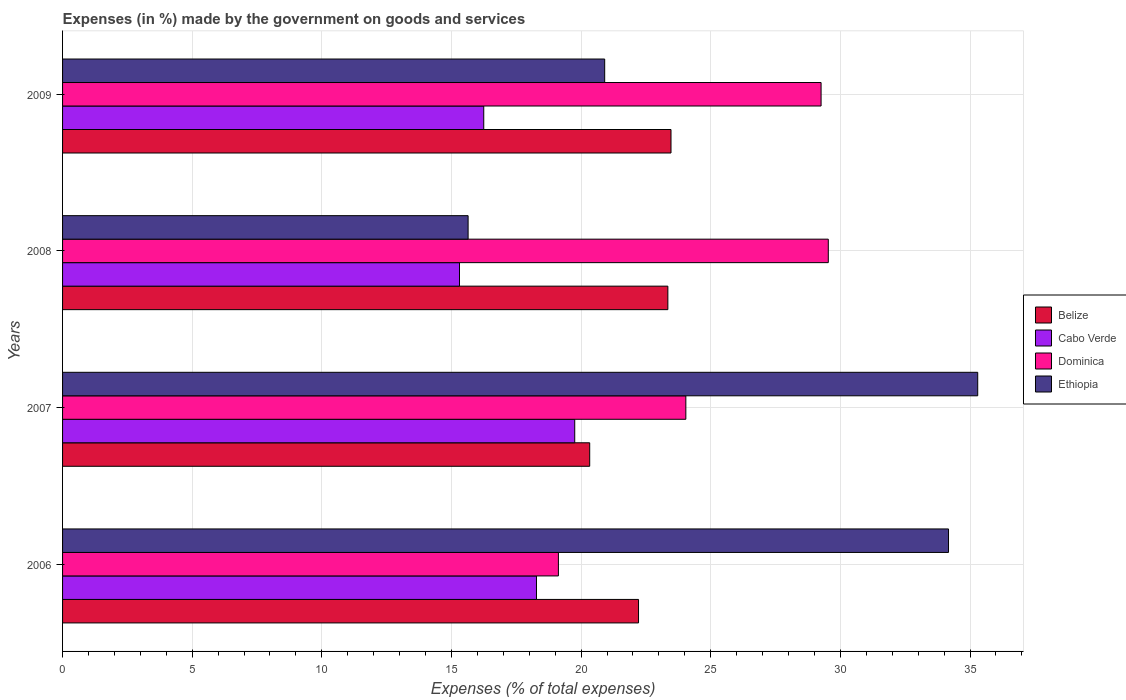How many bars are there on the 4th tick from the bottom?
Offer a very short reply. 4. In how many cases, is the number of bars for a given year not equal to the number of legend labels?
Keep it short and to the point. 0. What is the percentage of expenses made by the government on goods and services in Dominica in 2006?
Provide a succinct answer. 19.12. Across all years, what is the maximum percentage of expenses made by the government on goods and services in Ethiopia?
Provide a short and direct response. 35.3. Across all years, what is the minimum percentage of expenses made by the government on goods and services in Cabo Verde?
Your answer should be compact. 15.31. In which year was the percentage of expenses made by the government on goods and services in Cabo Verde minimum?
Offer a very short reply. 2008. What is the total percentage of expenses made by the government on goods and services in Belize in the graph?
Offer a very short reply. 89.36. What is the difference between the percentage of expenses made by the government on goods and services in Belize in 2007 and that in 2009?
Make the answer very short. -3.14. What is the difference between the percentage of expenses made by the government on goods and services in Cabo Verde in 2009 and the percentage of expenses made by the government on goods and services in Dominica in 2007?
Your answer should be very brief. -7.79. What is the average percentage of expenses made by the government on goods and services in Dominica per year?
Your answer should be compact. 25.49. In the year 2008, what is the difference between the percentage of expenses made by the government on goods and services in Belize and percentage of expenses made by the government on goods and services in Ethiopia?
Your answer should be very brief. 7.7. What is the ratio of the percentage of expenses made by the government on goods and services in Cabo Verde in 2006 to that in 2008?
Offer a very short reply. 1.19. Is the difference between the percentage of expenses made by the government on goods and services in Belize in 2006 and 2009 greater than the difference between the percentage of expenses made by the government on goods and services in Ethiopia in 2006 and 2009?
Ensure brevity in your answer.  No. What is the difference between the highest and the second highest percentage of expenses made by the government on goods and services in Ethiopia?
Keep it short and to the point. 1.13. What is the difference between the highest and the lowest percentage of expenses made by the government on goods and services in Belize?
Your answer should be compact. 3.14. In how many years, is the percentage of expenses made by the government on goods and services in Dominica greater than the average percentage of expenses made by the government on goods and services in Dominica taken over all years?
Offer a terse response. 2. What does the 3rd bar from the top in 2008 represents?
Ensure brevity in your answer.  Cabo Verde. What does the 3rd bar from the bottom in 2007 represents?
Make the answer very short. Dominica. How many bars are there?
Your answer should be very brief. 16. How many years are there in the graph?
Offer a very short reply. 4. What is the difference between two consecutive major ticks on the X-axis?
Make the answer very short. 5. Are the values on the major ticks of X-axis written in scientific E-notation?
Provide a short and direct response. No. How many legend labels are there?
Keep it short and to the point. 4. How are the legend labels stacked?
Your answer should be very brief. Vertical. What is the title of the graph?
Keep it short and to the point. Expenses (in %) made by the government on goods and services. Does "Samoa" appear as one of the legend labels in the graph?
Provide a succinct answer. No. What is the label or title of the X-axis?
Your response must be concise. Expenses (% of total expenses). What is the label or title of the Y-axis?
Your answer should be very brief. Years. What is the Expenses (% of total expenses) of Belize in 2006?
Your answer should be compact. 22.21. What is the Expenses (% of total expenses) of Cabo Verde in 2006?
Make the answer very short. 18.28. What is the Expenses (% of total expenses) in Dominica in 2006?
Provide a short and direct response. 19.12. What is the Expenses (% of total expenses) of Ethiopia in 2006?
Your response must be concise. 34.17. What is the Expenses (% of total expenses) of Belize in 2007?
Provide a short and direct response. 20.33. What is the Expenses (% of total expenses) in Cabo Verde in 2007?
Make the answer very short. 19.75. What is the Expenses (% of total expenses) in Dominica in 2007?
Ensure brevity in your answer.  24.04. What is the Expenses (% of total expenses) in Ethiopia in 2007?
Provide a short and direct response. 35.3. What is the Expenses (% of total expenses) of Belize in 2008?
Provide a short and direct response. 23.35. What is the Expenses (% of total expenses) in Cabo Verde in 2008?
Make the answer very short. 15.31. What is the Expenses (% of total expenses) in Dominica in 2008?
Your answer should be very brief. 29.53. What is the Expenses (% of total expenses) of Ethiopia in 2008?
Your answer should be compact. 15.64. What is the Expenses (% of total expenses) of Belize in 2009?
Your answer should be very brief. 23.47. What is the Expenses (% of total expenses) in Cabo Verde in 2009?
Give a very brief answer. 16.24. What is the Expenses (% of total expenses) in Dominica in 2009?
Offer a very short reply. 29.25. What is the Expenses (% of total expenses) of Ethiopia in 2009?
Your answer should be compact. 20.91. Across all years, what is the maximum Expenses (% of total expenses) of Belize?
Your answer should be compact. 23.47. Across all years, what is the maximum Expenses (% of total expenses) of Cabo Verde?
Give a very brief answer. 19.75. Across all years, what is the maximum Expenses (% of total expenses) of Dominica?
Provide a succinct answer. 29.53. Across all years, what is the maximum Expenses (% of total expenses) in Ethiopia?
Give a very brief answer. 35.3. Across all years, what is the minimum Expenses (% of total expenses) of Belize?
Your response must be concise. 20.33. Across all years, what is the minimum Expenses (% of total expenses) of Cabo Verde?
Your answer should be very brief. 15.31. Across all years, what is the minimum Expenses (% of total expenses) of Dominica?
Provide a short and direct response. 19.12. Across all years, what is the minimum Expenses (% of total expenses) of Ethiopia?
Offer a very short reply. 15.64. What is the total Expenses (% of total expenses) in Belize in the graph?
Make the answer very short. 89.36. What is the total Expenses (% of total expenses) of Cabo Verde in the graph?
Offer a very short reply. 69.59. What is the total Expenses (% of total expenses) in Dominica in the graph?
Make the answer very short. 101.95. What is the total Expenses (% of total expenses) of Ethiopia in the graph?
Offer a very short reply. 106.02. What is the difference between the Expenses (% of total expenses) of Belize in 2006 and that in 2007?
Keep it short and to the point. 1.88. What is the difference between the Expenses (% of total expenses) of Cabo Verde in 2006 and that in 2007?
Ensure brevity in your answer.  -1.48. What is the difference between the Expenses (% of total expenses) of Dominica in 2006 and that in 2007?
Your answer should be compact. -4.92. What is the difference between the Expenses (% of total expenses) in Ethiopia in 2006 and that in 2007?
Offer a very short reply. -1.13. What is the difference between the Expenses (% of total expenses) in Belize in 2006 and that in 2008?
Provide a succinct answer. -1.13. What is the difference between the Expenses (% of total expenses) of Cabo Verde in 2006 and that in 2008?
Offer a terse response. 2.97. What is the difference between the Expenses (% of total expenses) of Dominica in 2006 and that in 2008?
Make the answer very short. -10.41. What is the difference between the Expenses (% of total expenses) of Ethiopia in 2006 and that in 2008?
Keep it short and to the point. 18.53. What is the difference between the Expenses (% of total expenses) of Belize in 2006 and that in 2009?
Offer a terse response. -1.25. What is the difference between the Expenses (% of total expenses) of Cabo Verde in 2006 and that in 2009?
Offer a terse response. 2.03. What is the difference between the Expenses (% of total expenses) of Dominica in 2006 and that in 2009?
Offer a terse response. -10.13. What is the difference between the Expenses (% of total expenses) in Ethiopia in 2006 and that in 2009?
Offer a very short reply. 13.26. What is the difference between the Expenses (% of total expenses) of Belize in 2007 and that in 2008?
Make the answer very short. -3.01. What is the difference between the Expenses (% of total expenses) in Cabo Verde in 2007 and that in 2008?
Offer a terse response. 4.44. What is the difference between the Expenses (% of total expenses) in Dominica in 2007 and that in 2008?
Give a very brief answer. -5.49. What is the difference between the Expenses (% of total expenses) in Ethiopia in 2007 and that in 2008?
Offer a very short reply. 19.65. What is the difference between the Expenses (% of total expenses) in Belize in 2007 and that in 2009?
Your answer should be compact. -3.14. What is the difference between the Expenses (% of total expenses) of Cabo Verde in 2007 and that in 2009?
Your response must be concise. 3.51. What is the difference between the Expenses (% of total expenses) of Dominica in 2007 and that in 2009?
Ensure brevity in your answer.  -5.22. What is the difference between the Expenses (% of total expenses) in Ethiopia in 2007 and that in 2009?
Offer a terse response. 14.39. What is the difference between the Expenses (% of total expenses) of Belize in 2008 and that in 2009?
Give a very brief answer. -0.12. What is the difference between the Expenses (% of total expenses) in Cabo Verde in 2008 and that in 2009?
Keep it short and to the point. -0.94. What is the difference between the Expenses (% of total expenses) of Dominica in 2008 and that in 2009?
Offer a terse response. 0.28. What is the difference between the Expenses (% of total expenses) of Ethiopia in 2008 and that in 2009?
Provide a succinct answer. -5.27. What is the difference between the Expenses (% of total expenses) of Belize in 2006 and the Expenses (% of total expenses) of Cabo Verde in 2007?
Your answer should be compact. 2.46. What is the difference between the Expenses (% of total expenses) in Belize in 2006 and the Expenses (% of total expenses) in Dominica in 2007?
Offer a terse response. -1.82. What is the difference between the Expenses (% of total expenses) in Belize in 2006 and the Expenses (% of total expenses) in Ethiopia in 2007?
Ensure brevity in your answer.  -13.08. What is the difference between the Expenses (% of total expenses) in Cabo Verde in 2006 and the Expenses (% of total expenses) in Dominica in 2007?
Provide a short and direct response. -5.76. What is the difference between the Expenses (% of total expenses) in Cabo Verde in 2006 and the Expenses (% of total expenses) in Ethiopia in 2007?
Your response must be concise. -17.02. What is the difference between the Expenses (% of total expenses) of Dominica in 2006 and the Expenses (% of total expenses) of Ethiopia in 2007?
Your answer should be compact. -16.17. What is the difference between the Expenses (% of total expenses) of Belize in 2006 and the Expenses (% of total expenses) of Cabo Verde in 2008?
Give a very brief answer. 6.9. What is the difference between the Expenses (% of total expenses) in Belize in 2006 and the Expenses (% of total expenses) in Dominica in 2008?
Make the answer very short. -7.32. What is the difference between the Expenses (% of total expenses) in Belize in 2006 and the Expenses (% of total expenses) in Ethiopia in 2008?
Your response must be concise. 6.57. What is the difference between the Expenses (% of total expenses) of Cabo Verde in 2006 and the Expenses (% of total expenses) of Dominica in 2008?
Offer a terse response. -11.26. What is the difference between the Expenses (% of total expenses) of Cabo Verde in 2006 and the Expenses (% of total expenses) of Ethiopia in 2008?
Ensure brevity in your answer.  2.64. What is the difference between the Expenses (% of total expenses) of Dominica in 2006 and the Expenses (% of total expenses) of Ethiopia in 2008?
Your answer should be very brief. 3.48. What is the difference between the Expenses (% of total expenses) in Belize in 2006 and the Expenses (% of total expenses) in Cabo Verde in 2009?
Your response must be concise. 5.97. What is the difference between the Expenses (% of total expenses) of Belize in 2006 and the Expenses (% of total expenses) of Dominica in 2009?
Your answer should be compact. -7.04. What is the difference between the Expenses (% of total expenses) of Belize in 2006 and the Expenses (% of total expenses) of Ethiopia in 2009?
Your answer should be compact. 1.3. What is the difference between the Expenses (% of total expenses) of Cabo Verde in 2006 and the Expenses (% of total expenses) of Dominica in 2009?
Provide a short and direct response. -10.98. What is the difference between the Expenses (% of total expenses) in Cabo Verde in 2006 and the Expenses (% of total expenses) in Ethiopia in 2009?
Your answer should be compact. -2.63. What is the difference between the Expenses (% of total expenses) of Dominica in 2006 and the Expenses (% of total expenses) of Ethiopia in 2009?
Offer a terse response. -1.79. What is the difference between the Expenses (% of total expenses) in Belize in 2007 and the Expenses (% of total expenses) in Cabo Verde in 2008?
Your answer should be compact. 5.02. What is the difference between the Expenses (% of total expenses) of Belize in 2007 and the Expenses (% of total expenses) of Dominica in 2008?
Make the answer very short. -9.2. What is the difference between the Expenses (% of total expenses) in Belize in 2007 and the Expenses (% of total expenses) in Ethiopia in 2008?
Make the answer very short. 4.69. What is the difference between the Expenses (% of total expenses) in Cabo Verde in 2007 and the Expenses (% of total expenses) in Dominica in 2008?
Your response must be concise. -9.78. What is the difference between the Expenses (% of total expenses) in Cabo Verde in 2007 and the Expenses (% of total expenses) in Ethiopia in 2008?
Your answer should be very brief. 4.11. What is the difference between the Expenses (% of total expenses) of Dominica in 2007 and the Expenses (% of total expenses) of Ethiopia in 2008?
Keep it short and to the point. 8.4. What is the difference between the Expenses (% of total expenses) in Belize in 2007 and the Expenses (% of total expenses) in Cabo Verde in 2009?
Your response must be concise. 4.09. What is the difference between the Expenses (% of total expenses) of Belize in 2007 and the Expenses (% of total expenses) of Dominica in 2009?
Offer a terse response. -8.92. What is the difference between the Expenses (% of total expenses) in Belize in 2007 and the Expenses (% of total expenses) in Ethiopia in 2009?
Your answer should be very brief. -0.58. What is the difference between the Expenses (% of total expenses) of Cabo Verde in 2007 and the Expenses (% of total expenses) of Dominica in 2009?
Your answer should be very brief. -9.5. What is the difference between the Expenses (% of total expenses) of Cabo Verde in 2007 and the Expenses (% of total expenses) of Ethiopia in 2009?
Your answer should be very brief. -1.16. What is the difference between the Expenses (% of total expenses) in Dominica in 2007 and the Expenses (% of total expenses) in Ethiopia in 2009?
Your answer should be very brief. 3.13. What is the difference between the Expenses (% of total expenses) of Belize in 2008 and the Expenses (% of total expenses) of Cabo Verde in 2009?
Provide a short and direct response. 7.1. What is the difference between the Expenses (% of total expenses) in Belize in 2008 and the Expenses (% of total expenses) in Dominica in 2009?
Your answer should be very brief. -5.91. What is the difference between the Expenses (% of total expenses) of Belize in 2008 and the Expenses (% of total expenses) of Ethiopia in 2009?
Your response must be concise. 2.44. What is the difference between the Expenses (% of total expenses) of Cabo Verde in 2008 and the Expenses (% of total expenses) of Dominica in 2009?
Ensure brevity in your answer.  -13.95. What is the difference between the Expenses (% of total expenses) of Cabo Verde in 2008 and the Expenses (% of total expenses) of Ethiopia in 2009?
Your response must be concise. -5.6. What is the difference between the Expenses (% of total expenses) in Dominica in 2008 and the Expenses (% of total expenses) in Ethiopia in 2009?
Give a very brief answer. 8.62. What is the average Expenses (% of total expenses) in Belize per year?
Ensure brevity in your answer.  22.34. What is the average Expenses (% of total expenses) of Cabo Verde per year?
Your answer should be very brief. 17.4. What is the average Expenses (% of total expenses) in Dominica per year?
Your response must be concise. 25.49. What is the average Expenses (% of total expenses) in Ethiopia per year?
Offer a very short reply. 26.5. In the year 2006, what is the difference between the Expenses (% of total expenses) of Belize and Expenses (% of total expenses) of Cabo Verde?
Your answer should be compact. 3.94. In the year 2006, what is the difference between the Expenses (% of total expenses) of Belize and Expenses (% of total expenses) of Dominica?
Give a very brief answer. 3.09. In the year 2006, what is the difference between the Expenses (% of total expenses) of Belize and Expenses (% of total expenses) of Ethiopia?
Your answer should be compact. -11.96. In the year 2006, what is the difference between the Expenses (% of total expenses) in Cabo Verde and Expenses (% of total expenses) in Dominica?
Give a very brief answer. -0.85. In the year 2006, what is the difference between the Expenses (% of total expenses) in Cabo Verde and Expenses (% of total expenses) in Ethiopia?
Provide a succinct answer. -15.89. In the year 2006, what is the difference between the Expenses (% of total expenses) in Dominica and Expenses (% of total expenses) in Ethiopia?
Keep it short and to the point. -15.05. In the year 2007, what is the difference between the Expenses (% of total expenses) of Belize and Expenses (% of total expenses) of Cabo Verde?
Your response must be concise. 0.58. In the year 2007, what is the difference between the Expenses (% of total expenses) of Belize and Expenses (% of total expenses) of Dominica?
Your response must be concise. -3.71. In the year 2007, what is the difference between the Expenses (% of total expenses) in Belize and Expenses (% of total expenses) in Ethiopia?
Make the answer very short. -14.97. In the year 2007, what is the difference between the Expenses (% of total expenses) in Cabo Verde and Expenses (% of total expenses) in Dominica?
Ensure brevity in your answer.  -4.29. In the year 2007, what is the difference between the Expenses (% of total expenses) of Cabo Verde and Expenses (% of total expenses) of Ethiopia?
Give a very brief answer. -15.54. In the year 2007, what is the difference between the Expenses (% of total expenses) of Dominica and Expenses (% of total expenses) of Ethiopia?
Your answer should be very brief. -11.26. In the year 2008, what is the difference between the Expenses (% of total expenses) in Belize and Expenses (% of total expenses) in Cabo Verde?
Keep it short and to the point. 8.04. In the year 2008, what is the difference between the Expenses (% of total expenses) of Belize and Expenses (% of total expenses) of Dominica?
Give a very brief answer. -6.19. In the year 2008, what is the difference between the Expenses (% of total expenses) in Belize and Expenses (% of total expenses) in Ethiopia?
Offer a terse response. 7.7. In the year 2008, what is the difference between the Expenses (% of total expenses) of Cabo Verde and Expenses (% of total expenses) of Dominica?
Give a very brief answer. -14.22. In the year 2008, what is the difference between the Expenses (% of total expenses) in Cabo Verde and Expenses (% of total expenses) in Ethiopia?
Give a very brief answer. -0.33. In the year 2008, what is the difference between the Expenses (% of total expenses) in Dominica and Expenses (% of total expenses) in Ethiopia?
Your response must be concise. 13.89. In the year 2009, what is the difference between the Expenses (% of total expenses) in Belize and Expenses (% of total expenses) in Cabo Verde?
Your answer should be very brief. 7.22. In the year 2009, what is the difference between the Expenses (% of total expenses) in Belize and Expenses (% of total expenses) in Dominica?
Offer a terse response. -5.79. In the year 2009, what is the difference between the Expenses (% of total expenses) in Belize and Expenses (% of total expenses) in Ethiopia?
Offer a very short reply. 2.56. In the year 2009, what is the difference between the Expenses (% of total expenses) in Cabo Verde and Expenses (% of total expenses) in Dominica?
Your answer should be very brief. -13.01. In the year 2009, what is the difference between the Expenses (% of total expenses) of Cabo Verde and Expenses (% of total expenses) of Ethiopia?
Offer a terse response. -4.66. In the year 2009, what is the difference between the Expenses (% of total expenses) in Dominica and Expenses (% of total expenses) in Ethiopia?
Offer a very short reply. 8.35. What is the ratio of the Expenses (% of total expenses) in Belize in 2006 to that in 2007?
Make the answer very short. 1.09. What is the ratio of the Expenses (% of total expenses) in Cabo Verde in 2006 to that in 2007?
Keep it short and to the point. 0.93. What is the ratio of the Expenses (% of total expenses) of Dominica in 2006 to that in 2007?
Your answer should be compact. 0.8. What is the ratio of the Expenses (% of total expenses) of Ethiopia in 2006 to that in 2007?
Offer a terse response. 0.97. What is the ratio of the Expenses (% of total expenses) of Belize in 2006 to that in 2008?
Your response must be concise. 0.95. What is the ratio of the Expenses (% of total expenses) in Cabo Verde in 2006 to that in 2008?
Ensure brevity in your answer.  1.19. What is the ratio of the Expenses (% of total expenses) of Dominica in 2006 to that in 2008?
Offer a very short reply. 0.65. What is the ratio of the Expenses (% of total expenses) in Ethiopia in 2006 to that in 2008?
Offer a terse response. 2.18. What is the ratio of the Expenses (% of total expenses) of Belize in 2006 to that in 2009?
Your answer should be compact. 0.95. What is the ratio of the Expenses (% of total expenses) in Cabo Verde in 2006 to that in 2009?
Provide a succinct answer. 1.13. What is the ratio of the Expenses (% of total expenses) in Dominica in 2006 to that in 2009?
Your answer should be very brief. 0.65. What is the ratio of the Expenses (% of total expenses) of Ethiopia in 2006 to that in 2009?
Provide a short and direct response. 1.63. What is the ratio of the Expenses (% of total expenses) in Belize in 2007 to that in 2008?
Ensure brevity in your answer.  0.87. What is the ratio of the Expenses (% of total expenses) in Cabo Verde in 2007 to that in 2008?
Keep it short and to the point. 1.29. What is the ratio of the Expenses (% of total expenses) of Dominica in 2007 to that in 2008?
Keep it short and to the point. 0.81. What is the ratio of the Expenses (% of total expenses) in Ethiopia in 2007 to that in 2008?
Provide a succinct answer. 2.26. What is the ratio of the Expenses (% of total expenses) of Belize in 2007 to that in 2009?
Your response must be concise. 0.87. What is the ratio of the Expenses (% of total expenses) in Cabo Verde in 2007 to that in 2009?
Offer a terse response. 1.22. What is the ratio of the Expenses (% of total expenses) in Dominica in 2007 to that in 2009?
Your answer should be very brief. 0.82. What is the ratio of the Expenses (% of total expenses) of Ethiopia in 2007 to that in 2009?
Keep it short and to the point. 1.69. What is the ratio of the Expenses (% of total expenses) of Belize in 2008 to that in 2009?
Offer a terse response. 0.99. What is the ratio of the Expenses (% of total expenses) of Cabo Verde in 2008 to that in 2009?
Your answer should be very brief. 0.94. What is the ratio of the Expenses (% of total expenses) in Dominica in 2008 to that in 2009?
Keep it short and to the point. 1.01. What is the ratio of the Expenses (% of total expenses) of Ethiopia in 2008 to that in 2009?
Provide a succinct answer. 0.75. What is the difference between the highest and the second highest Expenses (% of total expenses) in Belize?
Your answer should be very brief. 0.12. What is the difference between the highest and the second highest Expenses (% of total expenses) in Cabo Verde?
Keep it short and to the point. 1.48. What is the difference between the highest and the second highest Expenses (% of total expenses) in Dominica?
Make the answer very short. 0.28. What is the difference between the highest and the second highest Expenses (% of total expenses) of Ethiopia?
Your answer should be very brief. 1.13. What is the difference between the highest and the lowest Expenses (% of total expenses) in Belize?
Make the answer very short. 3.14. What is the difference between the highest and the lowest Expenses (% of total expenses) in Cabo Verde?
Provide a succinct answer. 4.44. What is the difference between the highest and the lowest Expenses (% of total expenses) in Dominica?
Give a very brief answer. 10.41. What is the difference between the highest and the lowest Expenses (% of total expenses) in Ethiopia?
Your answer should be very brief. 19.65. 